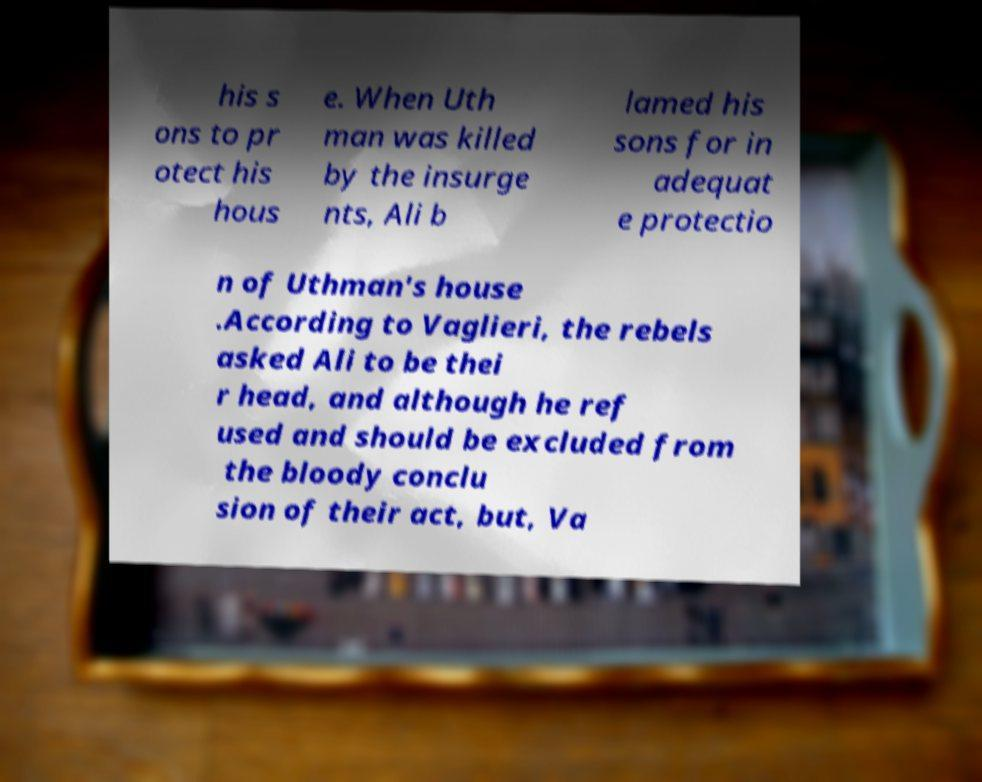Could you extract and type out the text from this image? his s ons to pr otect his hous e. When Uth man was killed by the insurge nts, Ali b lamed his sons for in adequat e protectio n of Uthman's house .According to Vaglieri, the rebels asked Ali to be thei r head, and although he ref used and should be excluded from the bloody conclu sion of their act, but, Va 